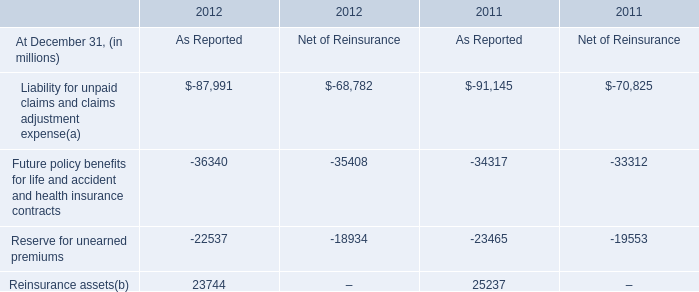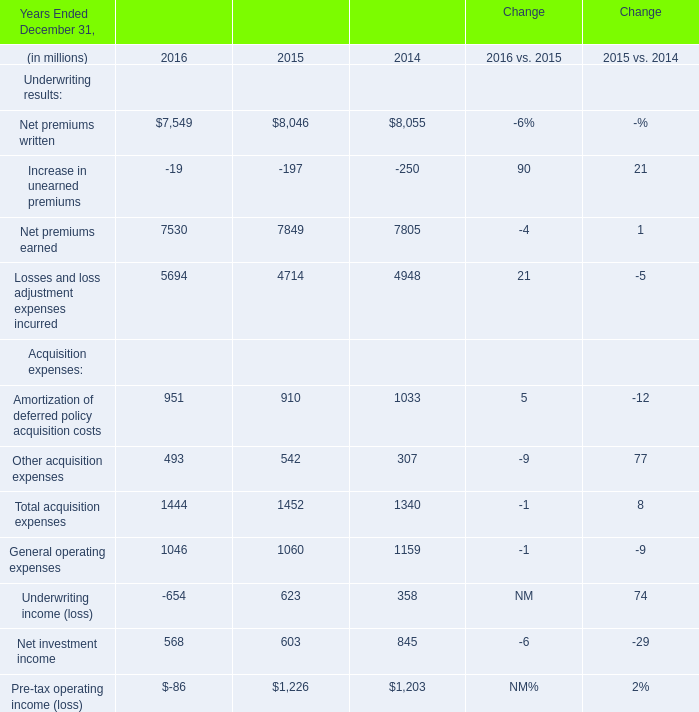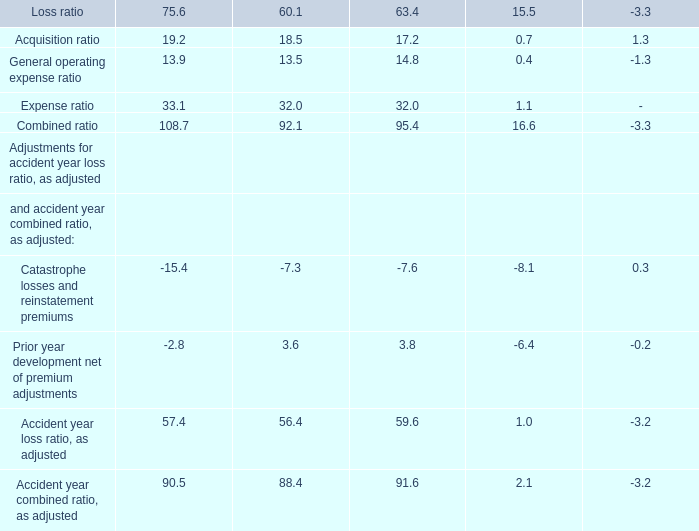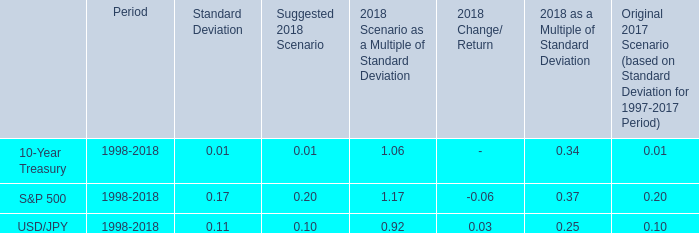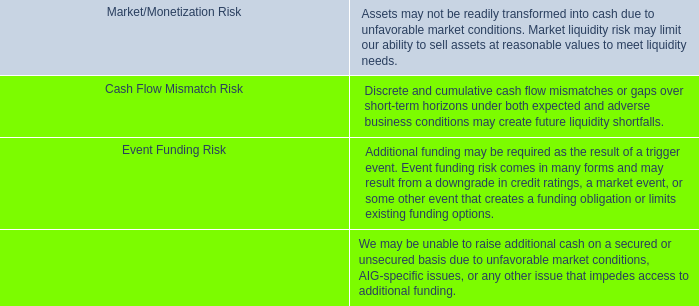What's the total amount of the Net premiums earned and Pre-tax operating income (loss) in the years where the Net premiums written is greater than 8050? (in doller) 
Computations: (7805 + 1203)
Answer: 9008.0. 